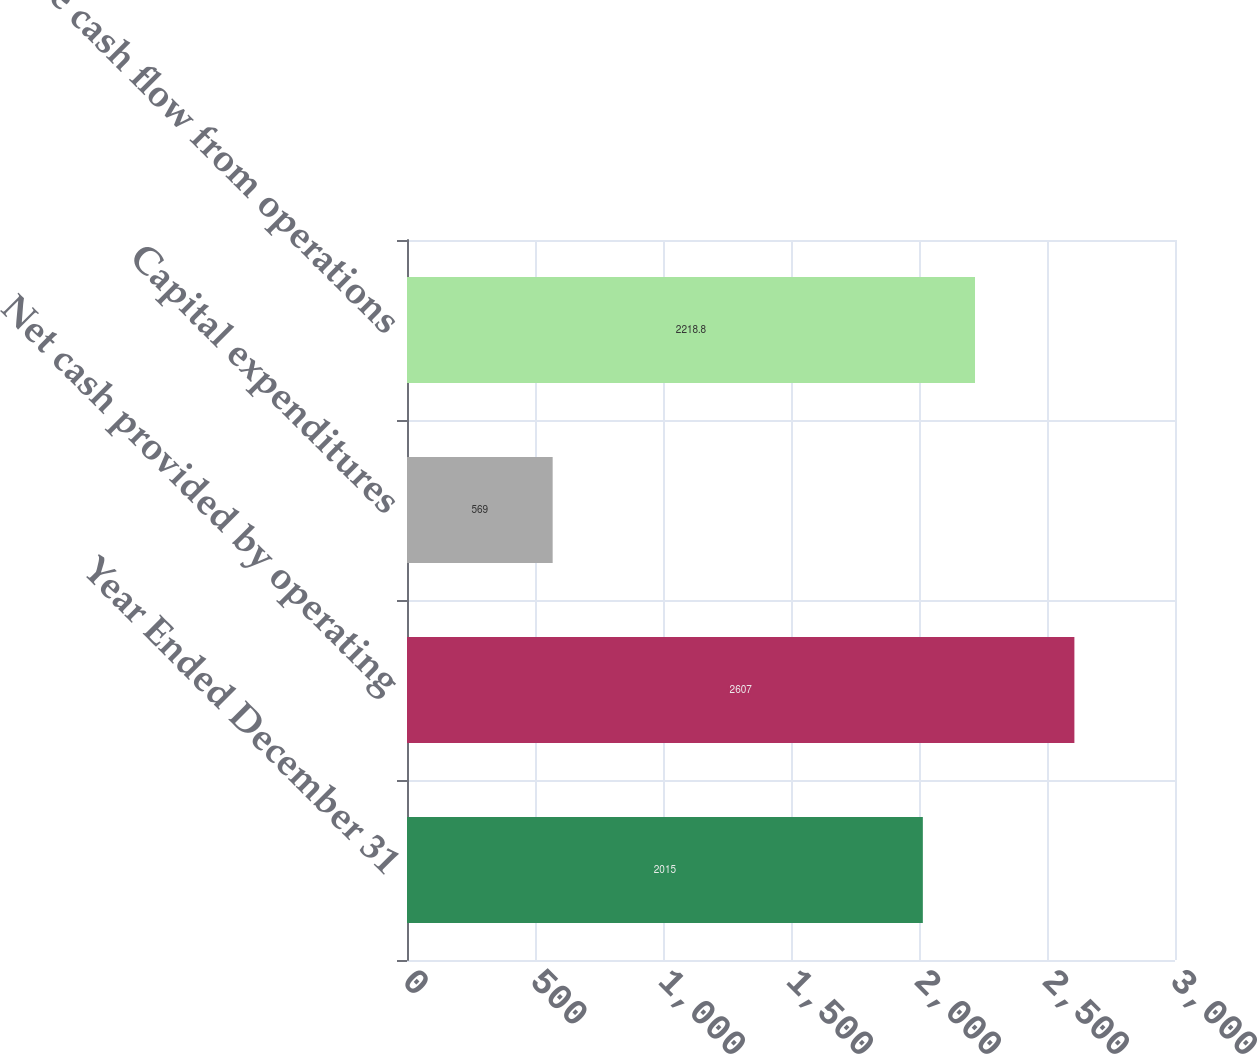Convert chart to OTSL. <chart><loc_0><loc_0><loc_500><loc_500><bar_chart><fcel>Year Ended December 31<fcel>Net cash provided by operating<fcel>Capital expenditures<fcel>Free cash flow from operations<nl><fcel>2015<fcel>2607<fcel>569<fcel>2218.8<nl></chart> 